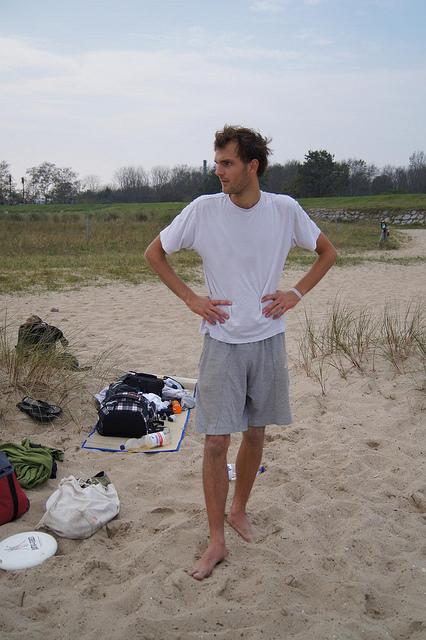Is there a rock formation with a hole in it?
Be succinct. No. Are the man's feet sandy?
Short answer required. Yes. What activity might he have been doing?
Keep it brief. Frisbee. How many legs is the man standing on?
Quick response, please. 2. Is it cold where this man is?
Give a very brief answer. No. What's on his shirt?
Quick response, please. Nothing. 